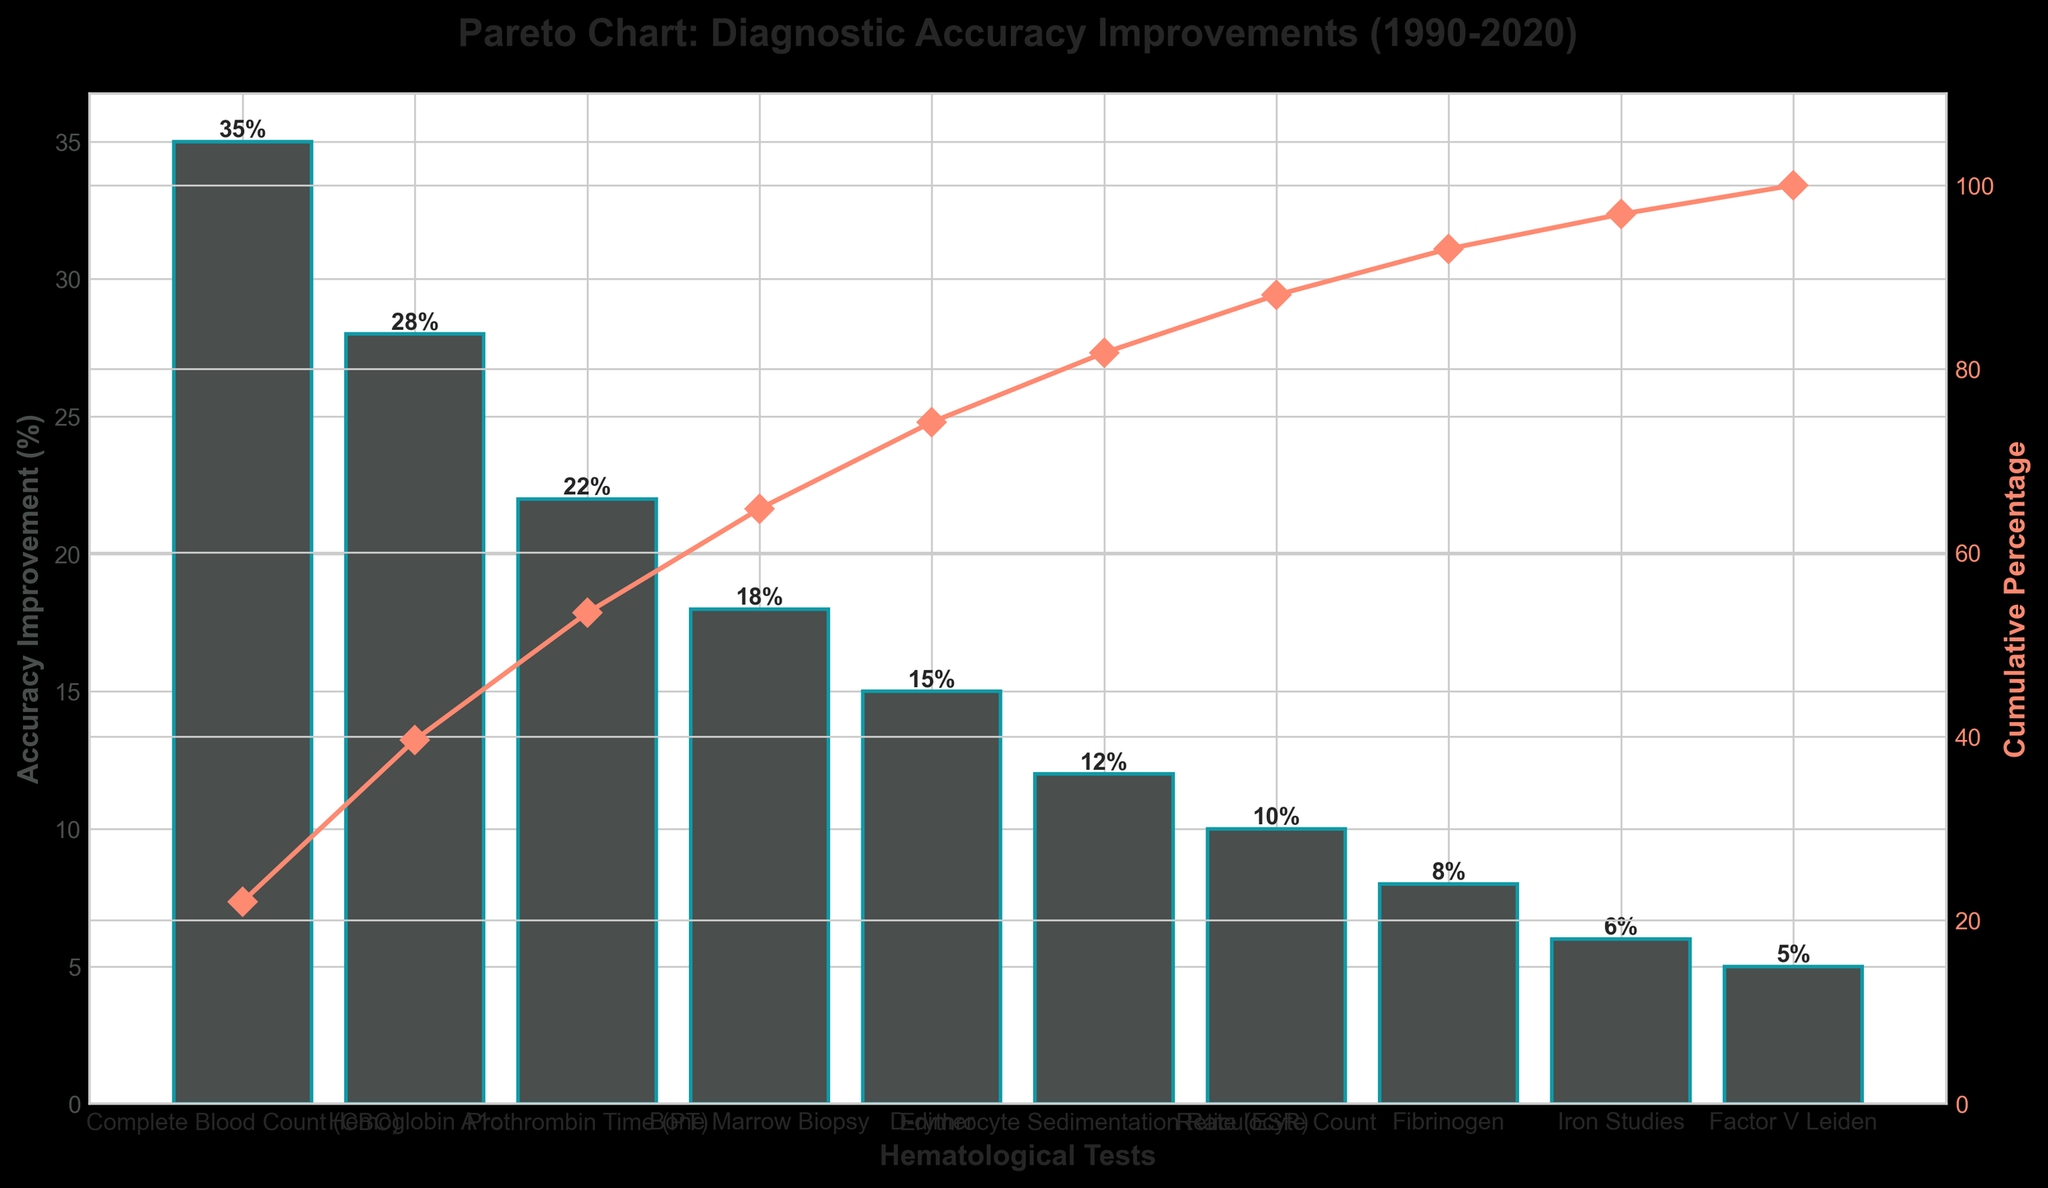What is the title of the chart? The title is displayed at the top of the chart and provides a summary of what the chart represents. In this case, it indicates that the chart is a Pareto chart showing diagnostic accuracy improvements from 1990 to 2020.
Answer: Pareto Chart: Diagnostic Accuracy Improvements (1990-2020) How many hematological tests show an accuracy improvement greater than 20%? The bars in the chart represent accuracy improvements for different tests. By looking for bars that extend above the 20% mark, we can count the number of tests that meet this criterion.
Answer: 3 Which test shows the highest diagnostic accuracy improvement? The test with the highest bar represents the greatest accuracy improvement. Looking at the bars, the "Complete Blood Count (CBC)" test has the highest bar.
Answer: Complete Blood Count (CBC) What is the cumulative percentage after the top three tests? The line in the chart represents the cumulative percentage. By following the line up to the third data point, we can see the cumulative percentage value. The top three tests are CBC, Hemoglobin A1c, and Prothrombin Time (PT).
Answer: 85% Which tests contribute to the cumulative percentage reaching over 90%? Follow the cumulative percentage line to the point where it crosses 90%. Track back to see which tests are included before this point. The tests include CBC, Hemoglobin A1c, PT, Bone Marrow Biopsy, and D-dimer.
Answer: CBC, Hemoglobin A1c, PT, Bone Marrow Biopsy, D-dimer What is the accuracy improvement for the Erythrocyte Sedimentation Rate (ESR) test? Locate the bar for the ESR test and read the height of the bar to determine the accuracy improvement percentage.
Answer: 12% Among "Bone Marrow Biopsy" and "D-dimer" tests, which has a lower accuracy improvement? Compare the heights of the bars representing Bone Marrow Biopsy and D-dimer. The bar for D-dimer is shorter.
Answer: D-dimer If we combine the accuracy improvements of "Factor V Leiden" and "Iron Studies" tests, what is the total improvement? Add the accuracy improvements shown on the bars for Factor V Leiden (5%) and Iron Studies (6%).
Answer: 11% How much lower is the improvement of the Reticulocyte Count test compared to the Complete Blood Count (CBC) test? Subtract the accuracy improvement of the Reticulocyte Count (10%) from that of the CBC (35%).
Answer: 25% What is the range of accuracy improvements shown in the chart? The range is the difference between the highest and lowest accuracy improvements. The highest is for CBC (35%) and the lowest is for Factor V Leiden (5%). Subtract 5% from 35%.
Answer: 30% 